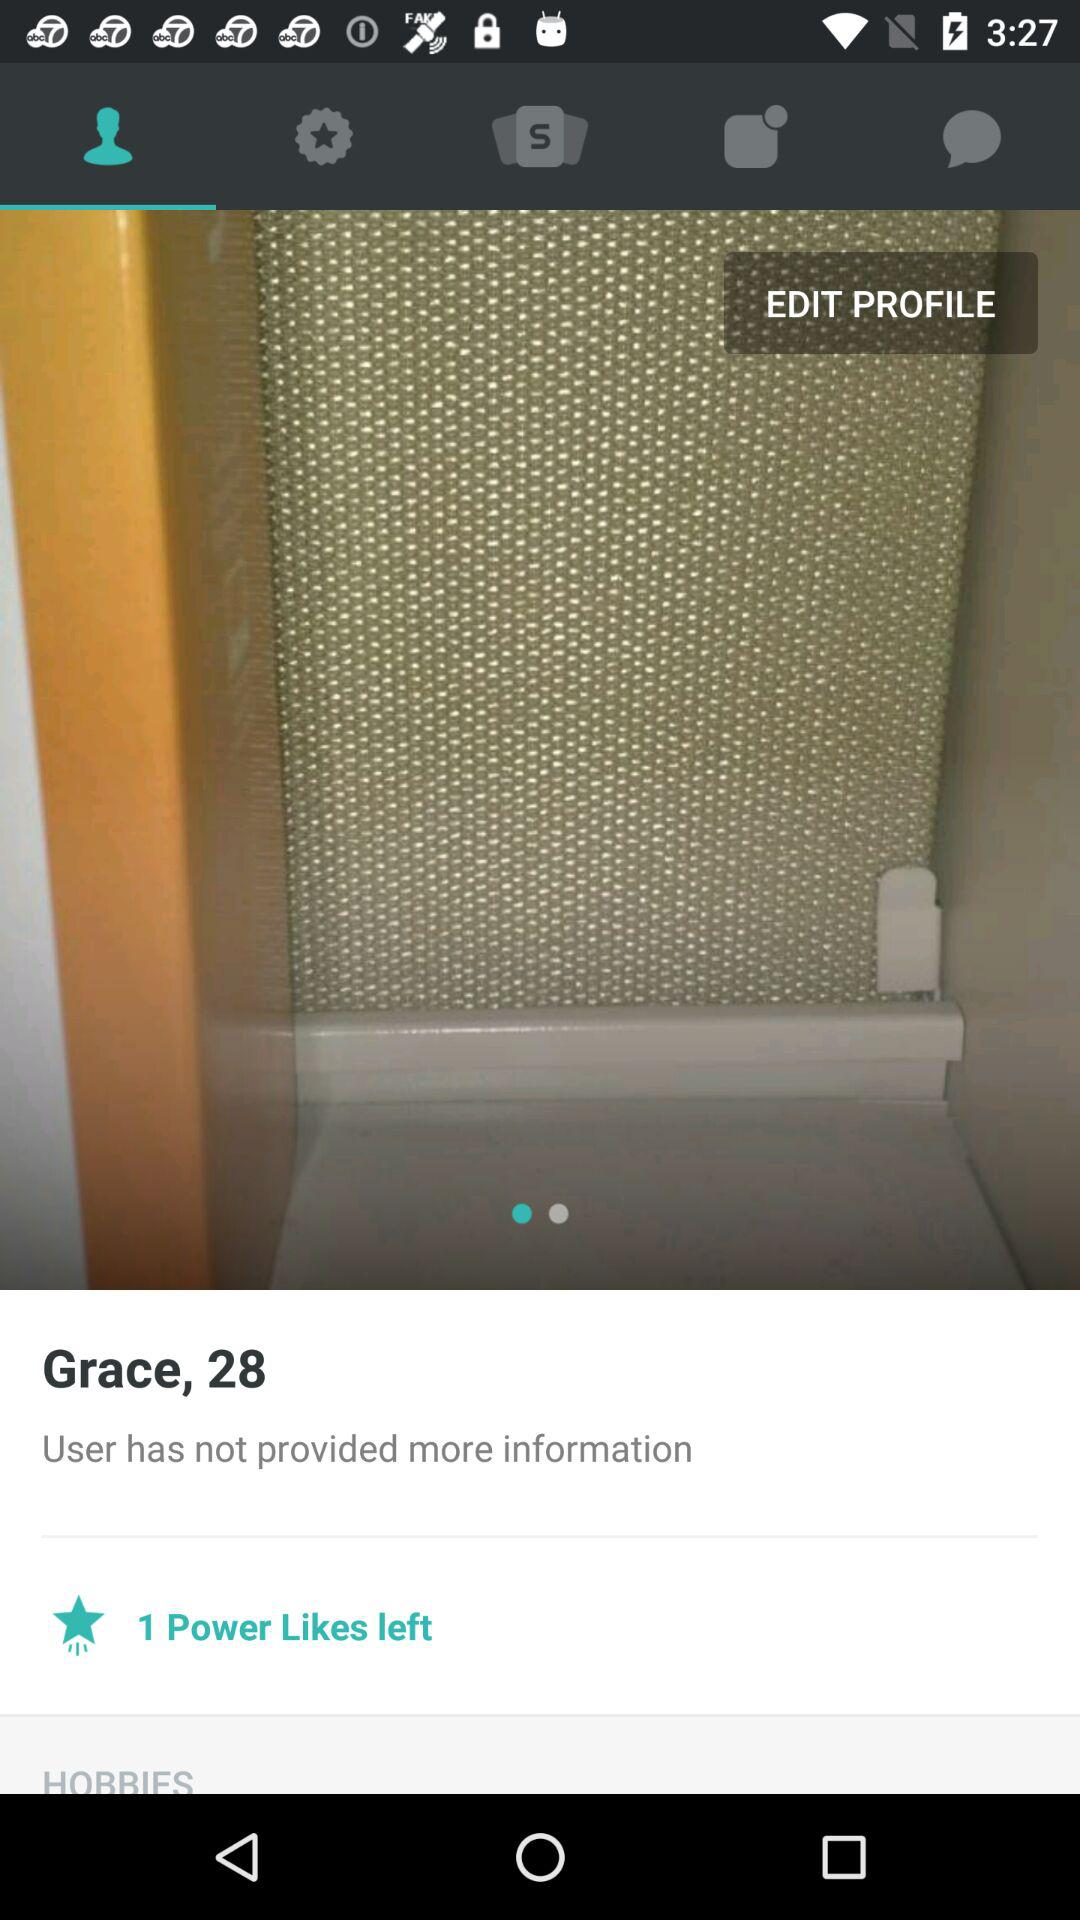How many power likes does Grace have left?
Answer the question using a single word or phrase. 1 